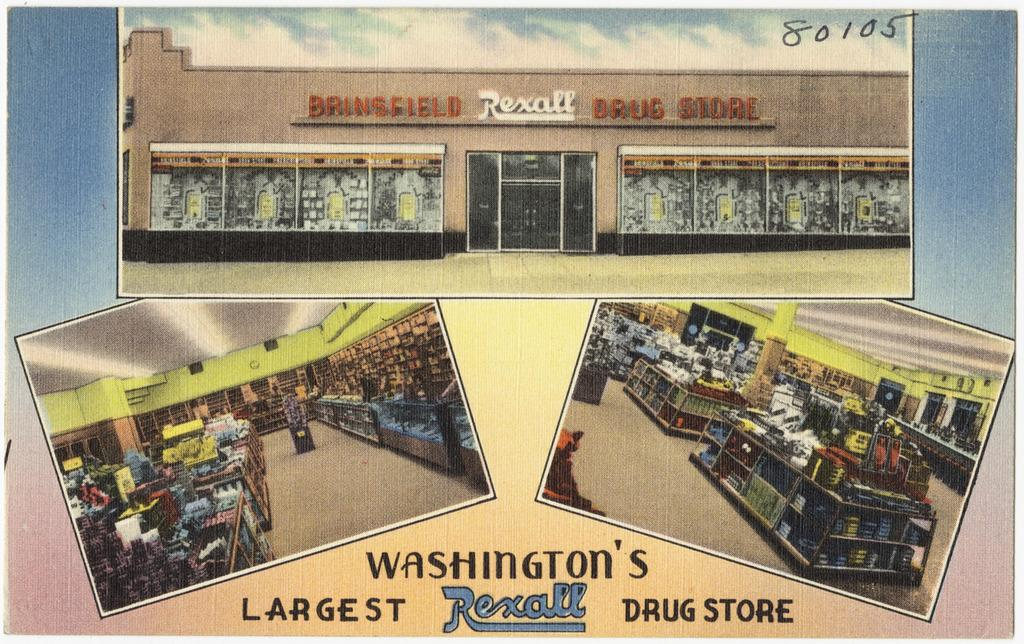Provide a one-sentence caption for the provided image. bringfield rexall drug store looks like a postcard. 